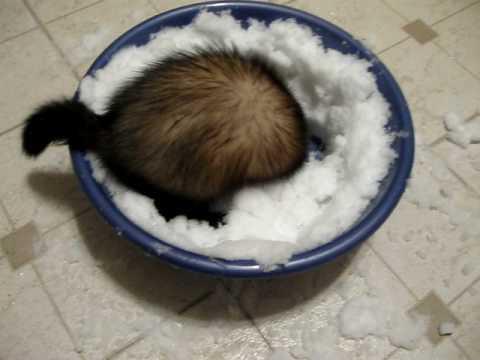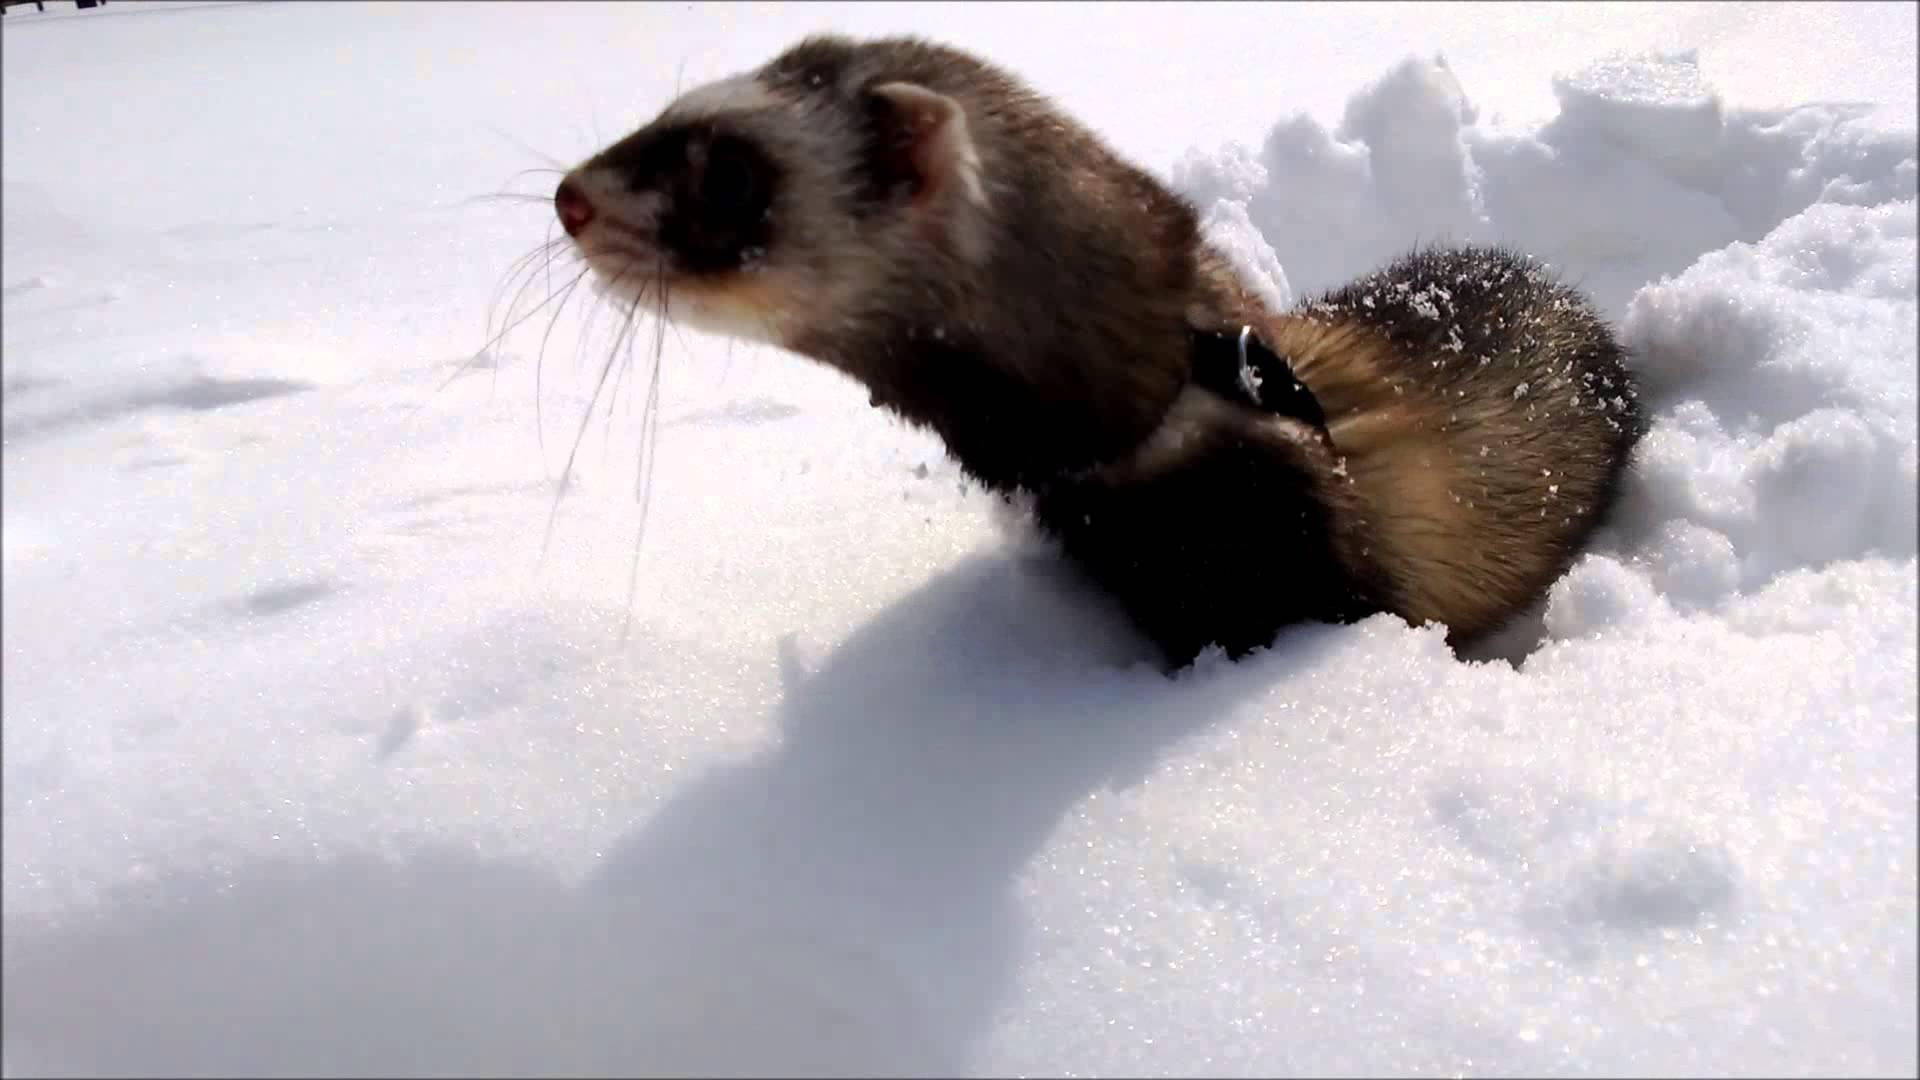The first image is the image on the left, the second image is the image on the right. For the images displayed, is the sentence "An image shows a ferret in a bowl of white fluff." factually correct? Answer yes or no. Yes. 